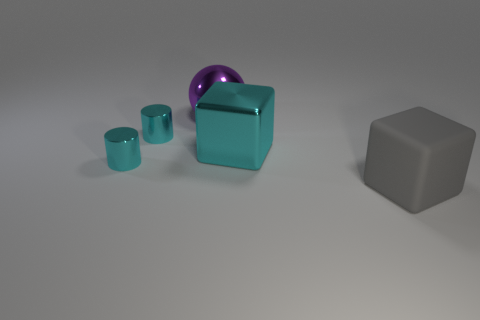How does the size of the purple sphere compare to the other objects? The purple sphere is smaller than the largest cyan cube but larger than the smallest objects in the image. Its size seems to be moderate, providing a pleasant contrast to the varying dimensions of the surrounding objects. 